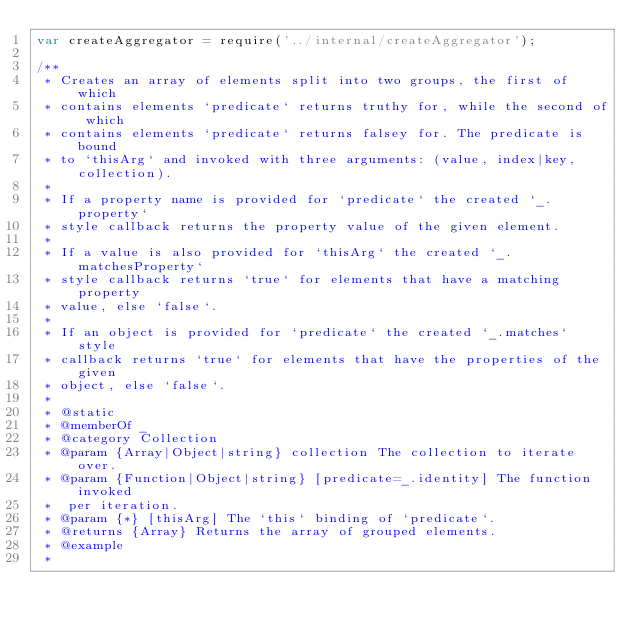<code> <loc_0><loc_0><loc_500><loc_500><_JavaScript_>var createAggregator = require('../internal/createAggregator');

/**
 * Creates an array of elements split into two groups, the first of which
 * contains elements `predicate` returns truthy for, while the second of which
 * contains elements `predicate` returns falsey for. The predicate is bound
 * to `thisArg` and invoked with three arguments: (value, index|key, collection).
 *
 * If a property name is provided for `predicate` the created `_.property`
 * style callback returns the property value of the given element.
 *
 * If a value is also provided for `thisArg` the created `_.matchesProperty`
 * style callback returns `true` for elements that have a matching property
 * value, else `false`.
 *
 * If an object is provided for `predicate` the created `_.matches` style
 * callback returns `true` for elements that have the properties of the given
 * object, else `false`.
 *
 * @static
 * @memberOf _
 * @category Collection
 * @param {Array|Object|string} collection The collection to iterate over.
 * @param {Function|Object|string} [predicate=_.identity] The function invoked
 *  per iteration.
 * @param {*} [thisArg] The `this` binding of `predicate`.
 * @returns {Array} Returns the array of grouped elements.
 * @example
 *</code> 